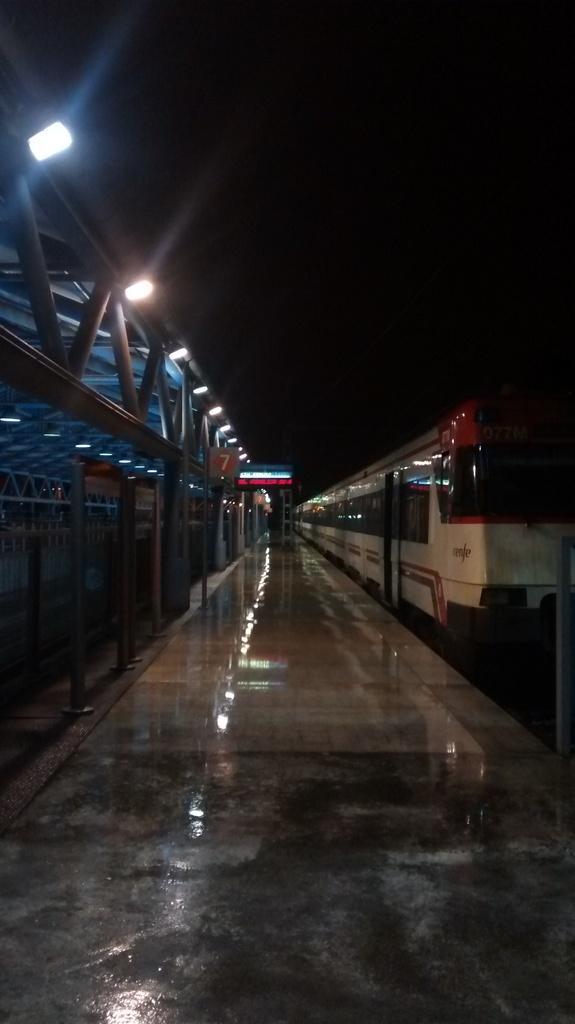How would you summarize this image in a sentence or two? In this image I can see a train in white and red color. I can see boards, lights and dark background. 